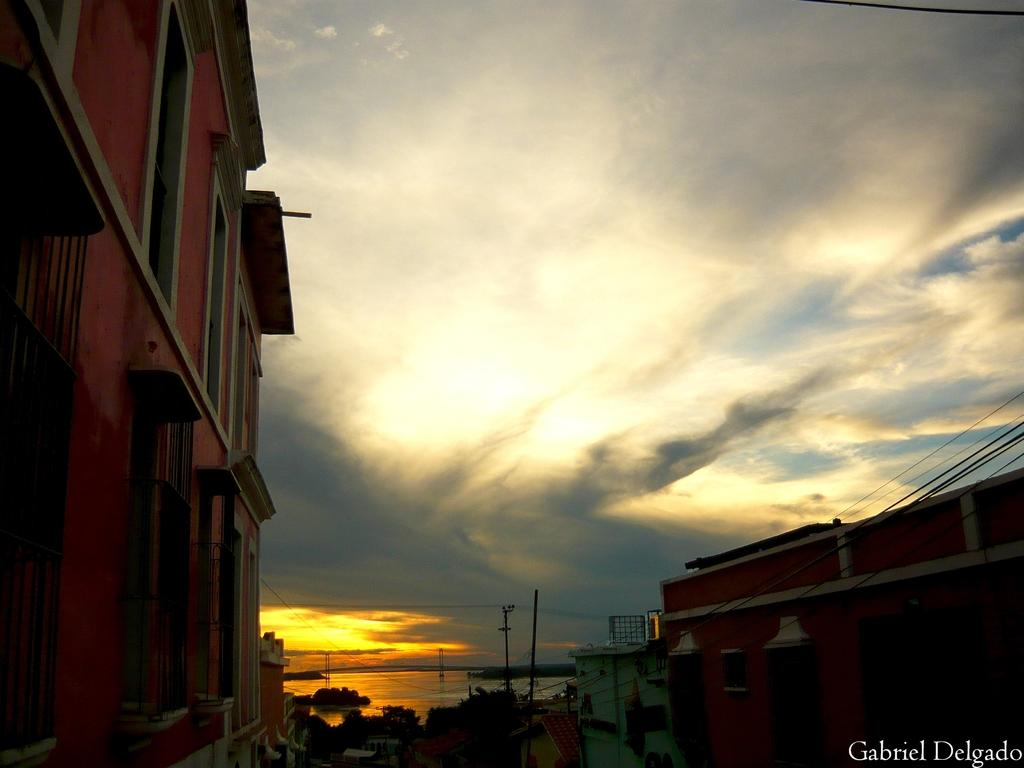What type of structures can be seen in the image? There are buildings in the image. What natural elements are present on the sides of the image? There are trees on either side of the image. What can be seen in the distance in the image? There is water visible in the background of the image. How would you describe the weather based on the image? The sky is cloudy in the image. How many ladybugs can be seen crawling on the buildings in the image? There are no ladybugs present in the image; it features buildings, trees, water, and a cloudy sky. 